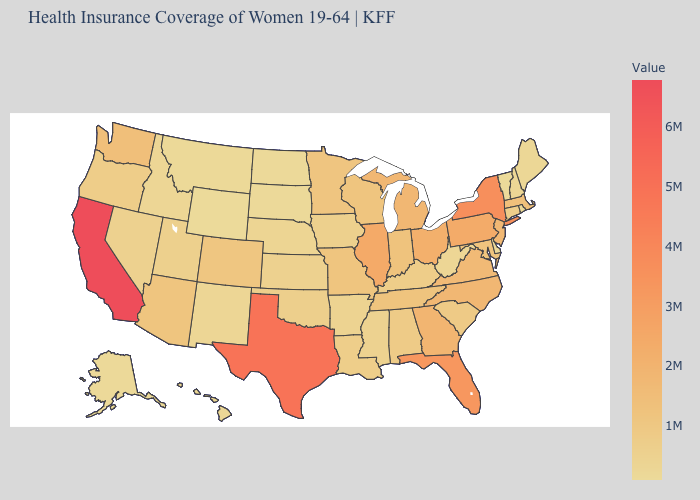Which states have the highest value in the USA?
Short answer required. California. Which states have the lowest value in the MidWest?
Write a very short answer. North Dakota. Which states have the lowest value in the Northeast?
Quick response, please. Vermont. Among the states that border New Hampshire , which have the lowest value?
Answer briefly. Vermont. Does Texas have the highest value in the South?
Keep it brief. Yes. Which states have the lowest value in the USA?
Short answer required. Wyoming. Which states hav the highest value in the South?
Short answer required. Texas. Among the states that border Arkansas , does Mississippi have the lowest value?
Keep it brief. Yes. 